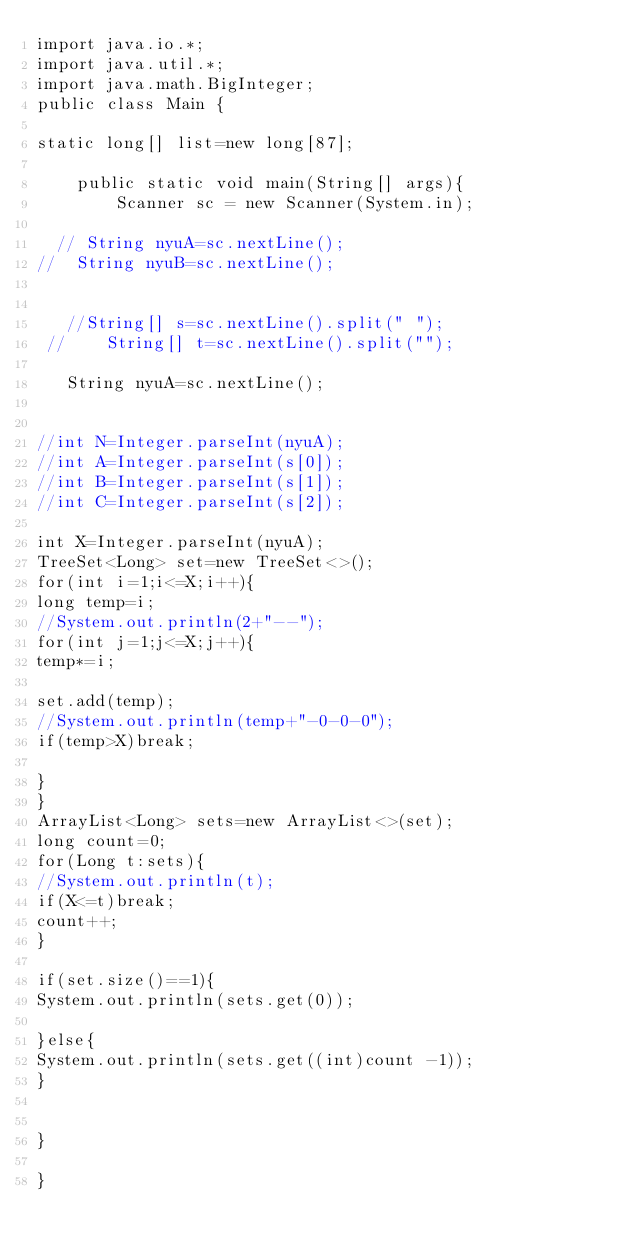Convert code to text. <code><loc_0><loc_0><loc_500><loc_500><_Java_>import java.io.*;
import java.util.*;
import java.math.BigInteger;
public class Main {

static long[] list=new long[87];

	public static void main(String[] args){
		Scanner sc = new Scanner(System.in);

  // String nyuA=sc.nextLine();
//  String nyuB=sc.nextLine(); 
 

   //String[] s=sc.nextLine().split(" ");
 //    String[] t=sc.nextLine().split("");

   String nyuA=sc.nextLine();


//int N=Integer.parseInt(nyuA);
//int A=Integer.parseInt(s[0]);
//int B=Integer.parseInt(s[1]);
//int C=Integer.parseInt(s[2]);

int X=Integer.parseInt(nyuA);
TreeSet<Long> set=new TreeSet<>();
for(int i=1;i<=X;i++){
long temp=i;
//System.out.println(2+"--");
for(int j=1;j<=X;j++){
temp*=i;

set.add(temp);
//System.out.println(temp+"-0-0-0");
if(temp>X)break;

}
}
ArrayList<Long> sets=new ArrayList<>(set);
long count=0;
for(Long t:sets){
//System.out.println(t);
if(X<=t)break;
count++;
}

if(set.size()==1){
System.out.println(sets.get(0));

}else{
System.out.println(sets.get((int)count -1));
}


}

}

</code> 